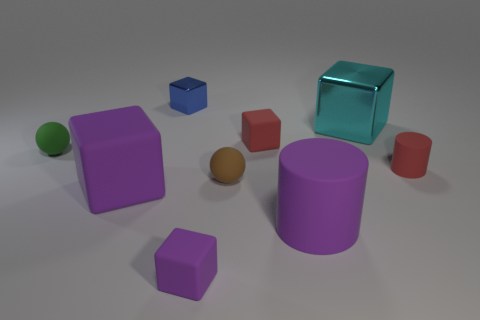There is a purple object that is in front of the large matte thing that is right of the large block in front of the small red rubber block; what is its size?
Make the answer very short. Small. There is a purple rubber thing that is on the left side of the metal block that is left of the small red cube; is there a block behind it?
Offer a very short reply. Yes. Is the number of brown things greater than the number of red objects?
Provide a short and direct response. No. What is the color of the cylinder that is right of the cyan cube?
Offer a very short reply. Red. Is the number of red matte cylinders that are in front of the large cylinder greater than the number of small green things?
Provide a succinct answer. No. Does the large cyan cube have the same material as the green object?
Your answer should be compact. No. How many other objects are there of the same shape as the green thing?
Ensure brevity in your answer.  1. Is there anything else that is made of the same material as the red cylinder?
Provide a short and direct response. Yes. The matte block that is behind the red matte thing on the right side of the small red object that is to the left of the cyan thing is what color?
Offer a terse response. Red. Do the small purple object that is left of the red block and the cyan metallic thing have the same shape?
Provide a succinct answer. Yes. 